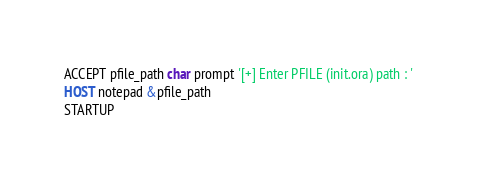<code> <loc_0><loc_0><loc_500><loc_500><_SQL_>ACCEPT pfile_path char prompt '[+] Enter PFILE (init.ora) path : '
HOST notepad &pfile_path
STARTUP
</code> 